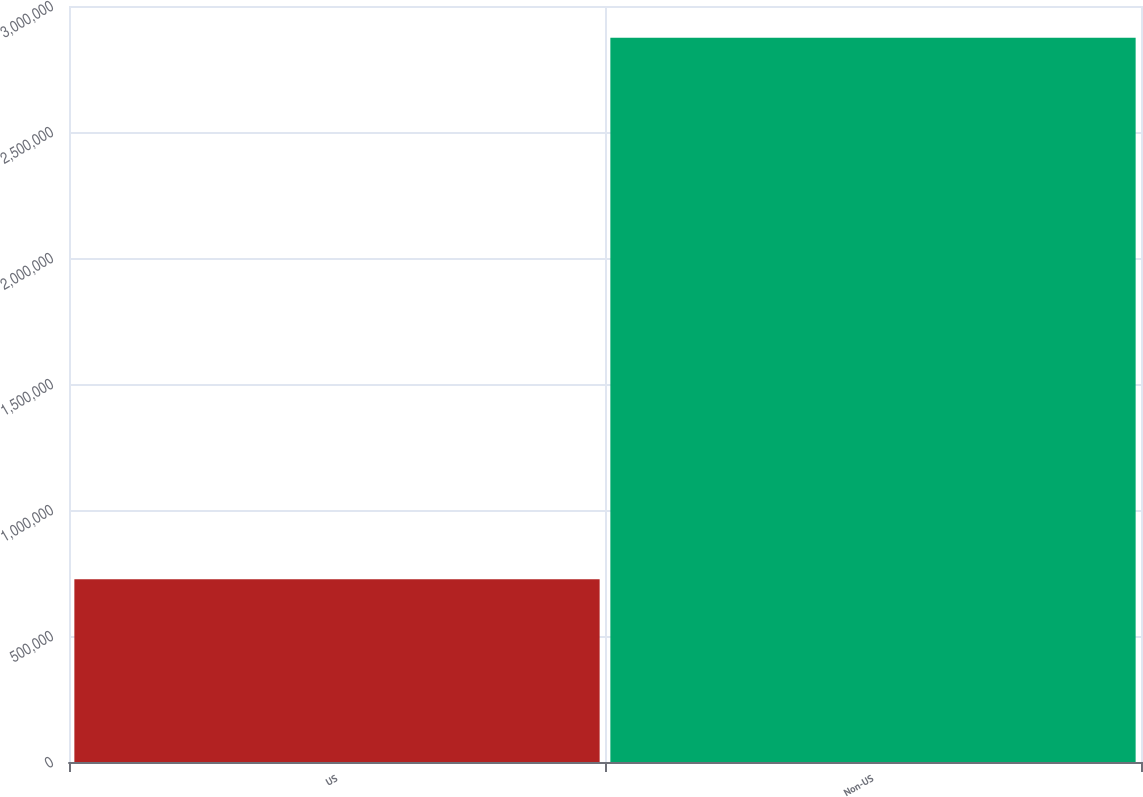<chart> <loc_0><loc_0><loc_500><loc_500><bar_chart><fcel>US<fcel>Non-US<nl><fcel>725000<fcel>2.874e+06<nl></chart> 